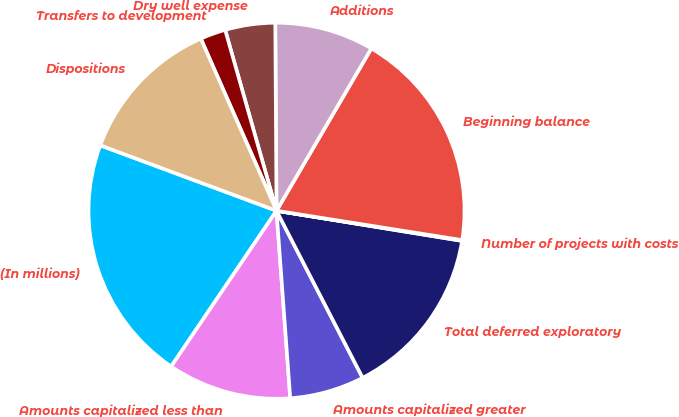Convert chart to OTSL. <chart><loc_0><loc_0><loc_500><loc_500><pie_chart><fcel>(In millions)<fcel>Amounts capitalized less than<fcel>Amounts capitalized greater<fcel>Total deferred exploratory<fcel>Number of projects with costs<fcel>Beginning balance<fcel>Additions<fcel>Dry well expense<fcel>Transfers to development<fcel>Dispositions<nl><fcel>21.19%<fcel>10.63%<fcel>6.41%<fcel>14.86%<fcel>0.07%<fcel>19.08%<fcel>8.52%<fcel>4.3%<fcel>2.19%<fcel>12.75%<nl></chart> 